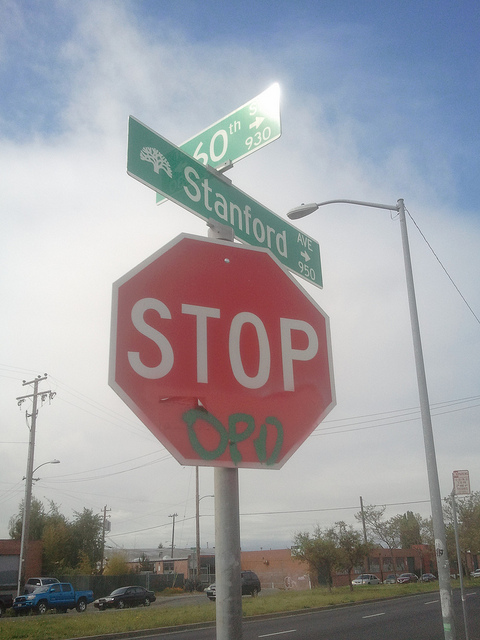Please extract the text content from this image. 50 t th 930 Stanford STOP 950 AVE OPO 